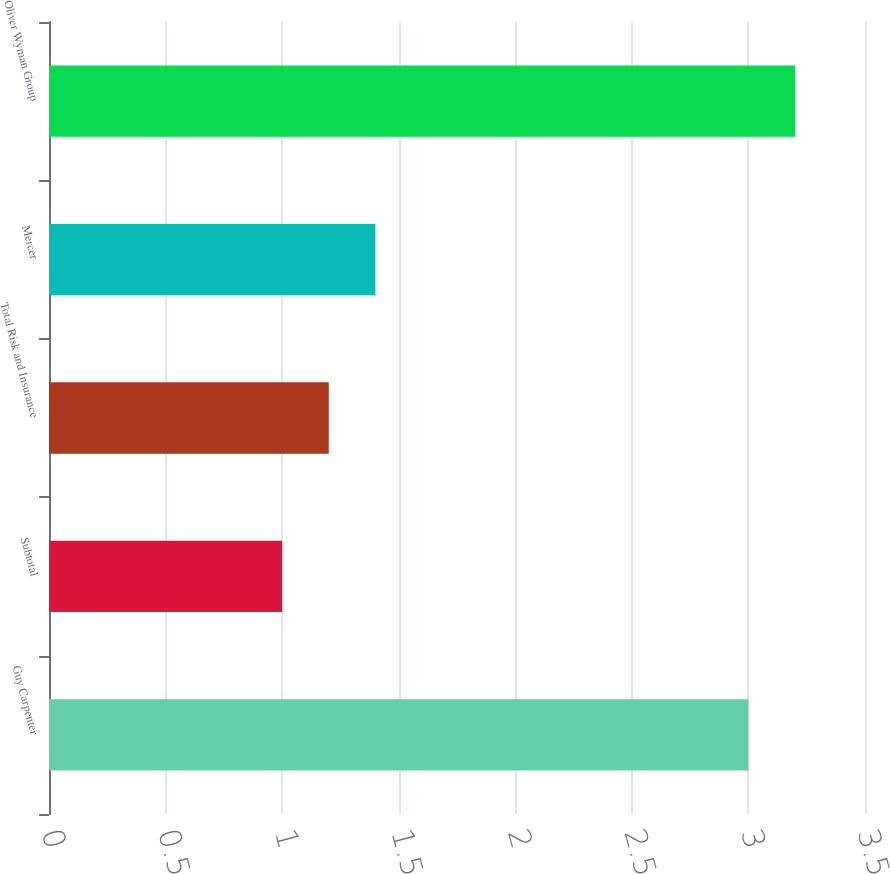Convert chart. <chart><loc_0><loc_0><loc_500><loc_500><bar_chart><fcel>Guy Carpenter<fcel>Subtotal<fcel>Total Risk and Insurance<fcel>Mercer<fcel>Oliver Wyman Group<nl><fcel>3<fcel>1<fcel>1.2<fcel>1.4<fcel>3.2<nl></chart> 